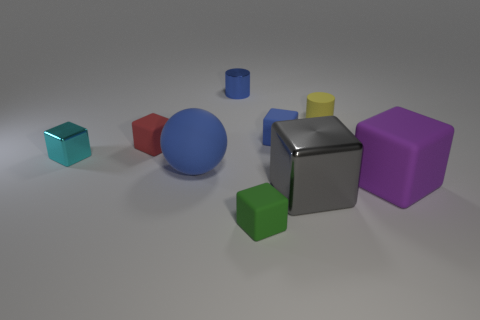Subtract all large purple blocks. How many blocks are left? 5 Subtract all green blocks. How many blocks are left? 5 Add 1 yellow rubber objects. How many objects exist? 10 Subtract 5 cubes. How many cubes are left? 1 Subtract all balls. How many objects are left? 8 Subtract all green blocks. Subtract all yellow spheres. How many blocks are left? 5 Subtract all cyan blocks. How many yellow cylinders are left? 1 Subtract all large brown rubber spheres. Subtract all small blue matte cubes. How many objects are left? 8 Add 7 gray metal blocks. How many gray metal blocks are left? 8 Add 2 yellow cubes. How many yellow cubes exist? 2 